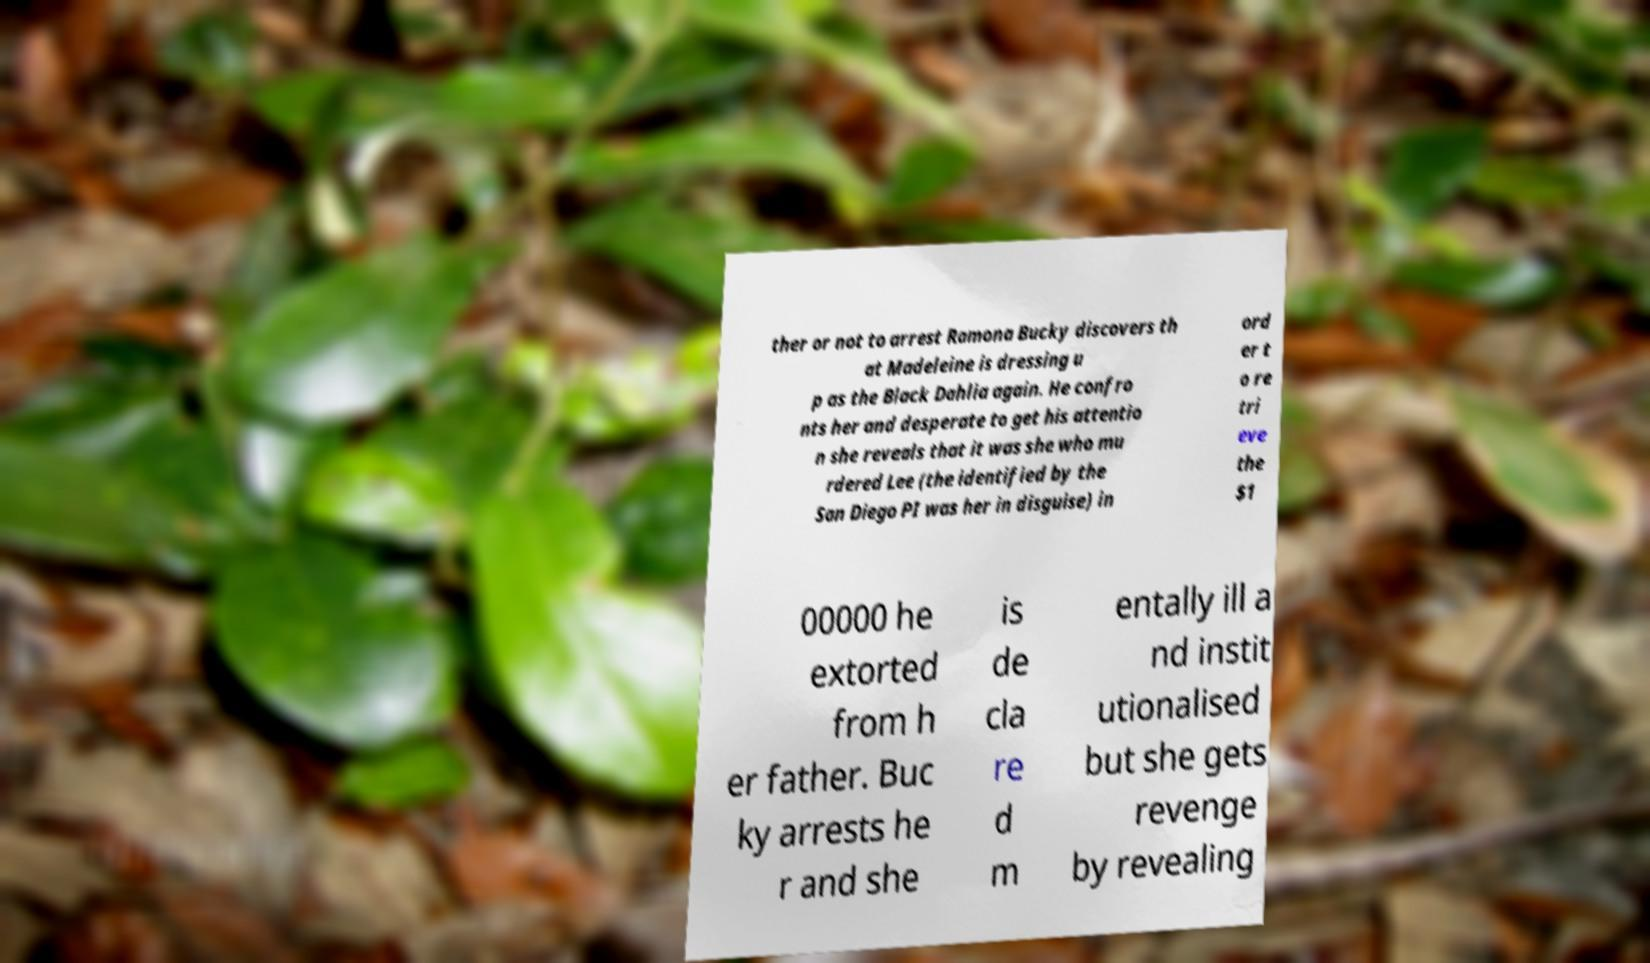There's text embedded in this image that I need extracted. Can you transcribe it verbatim? ther or not to arrest Ramona Bucky discovers th at Madeleine is dressing u p as the Black Dahlia again. He confro nts her and desperate to get his attentio n she reveals that it was she who mu rdered Lee (the identified by the San Diego PI was her in disguise) in ord er t o re tri eve the $1 00000 he extorted from h er father. Buc ky arrests he r and she is de cla re d m entally ill a nd instit utionalised but she gets revenge by revealing 